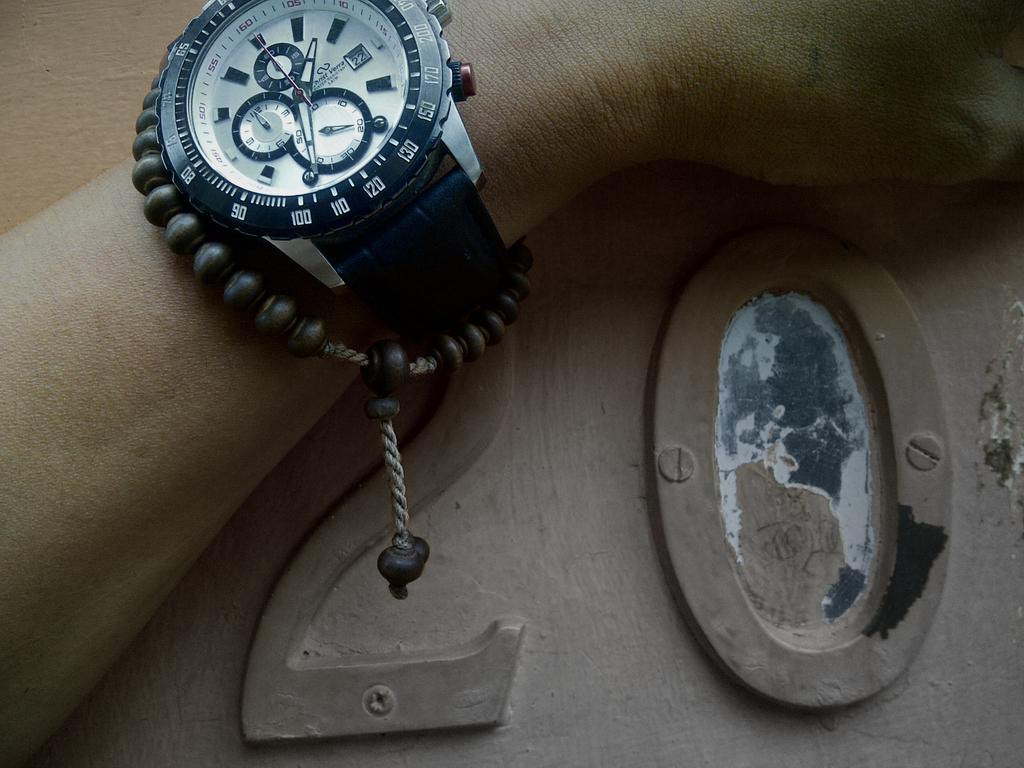<image>
Summarize the visual content of the image. A person holds their left arm against the door to room 20. 